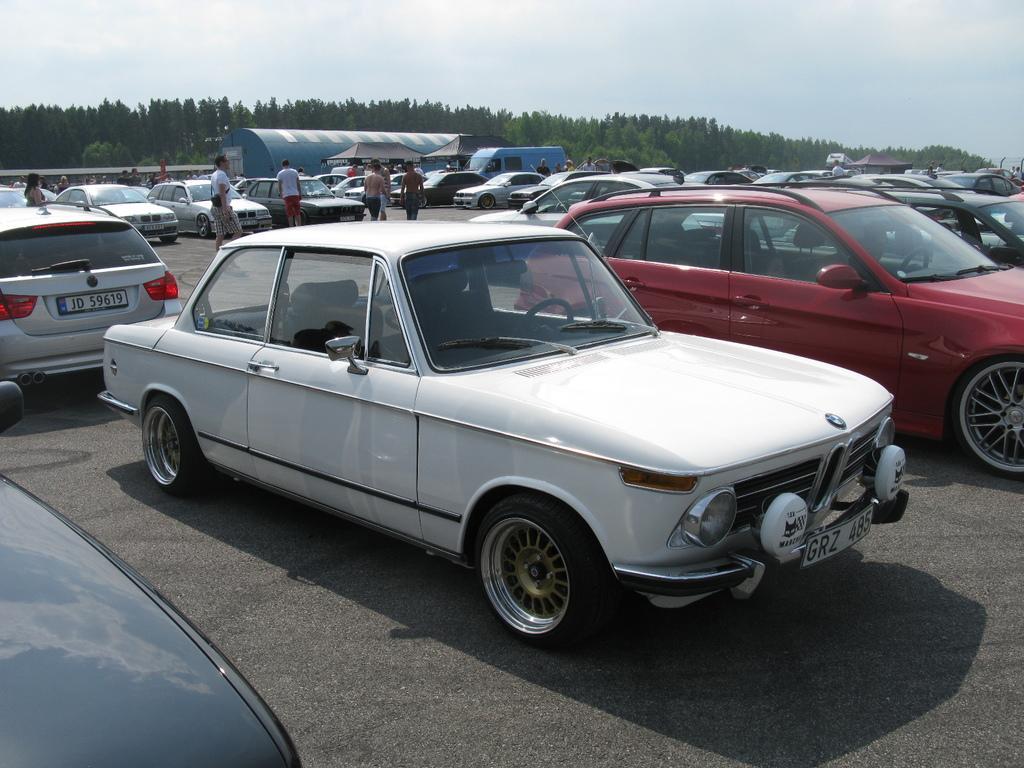How would you summarize this image in a sentence or two? In this picture we can see so many vehicles are parked in one place, few people are walking around, behind we can see shed and so many trees. 